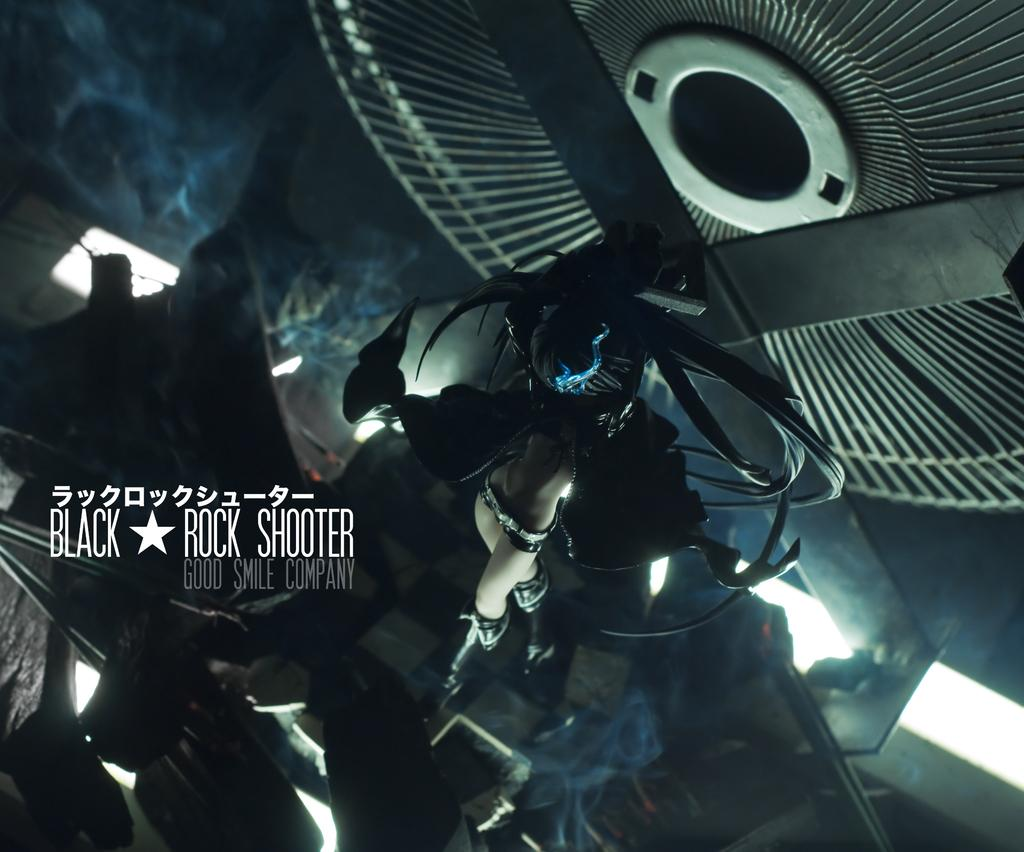<image>
Create a compact narrative representing the image presented. close up of inside of a fan and the words black rock shooter 